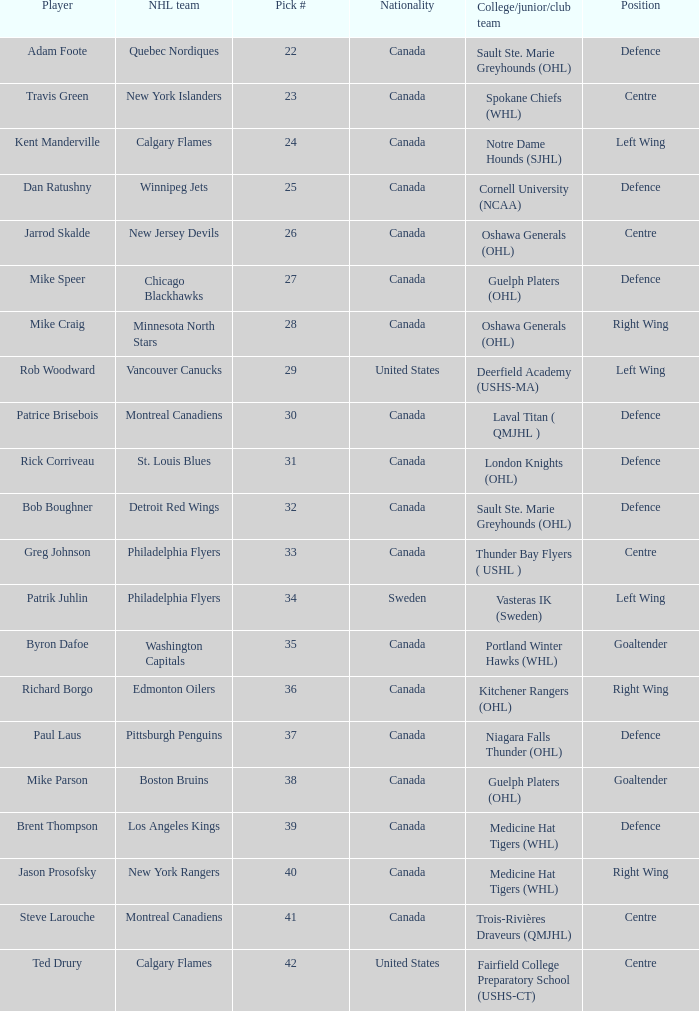What is the nationality of the draft pick player who plays centre position and is going to Calgary Flames? United States. 